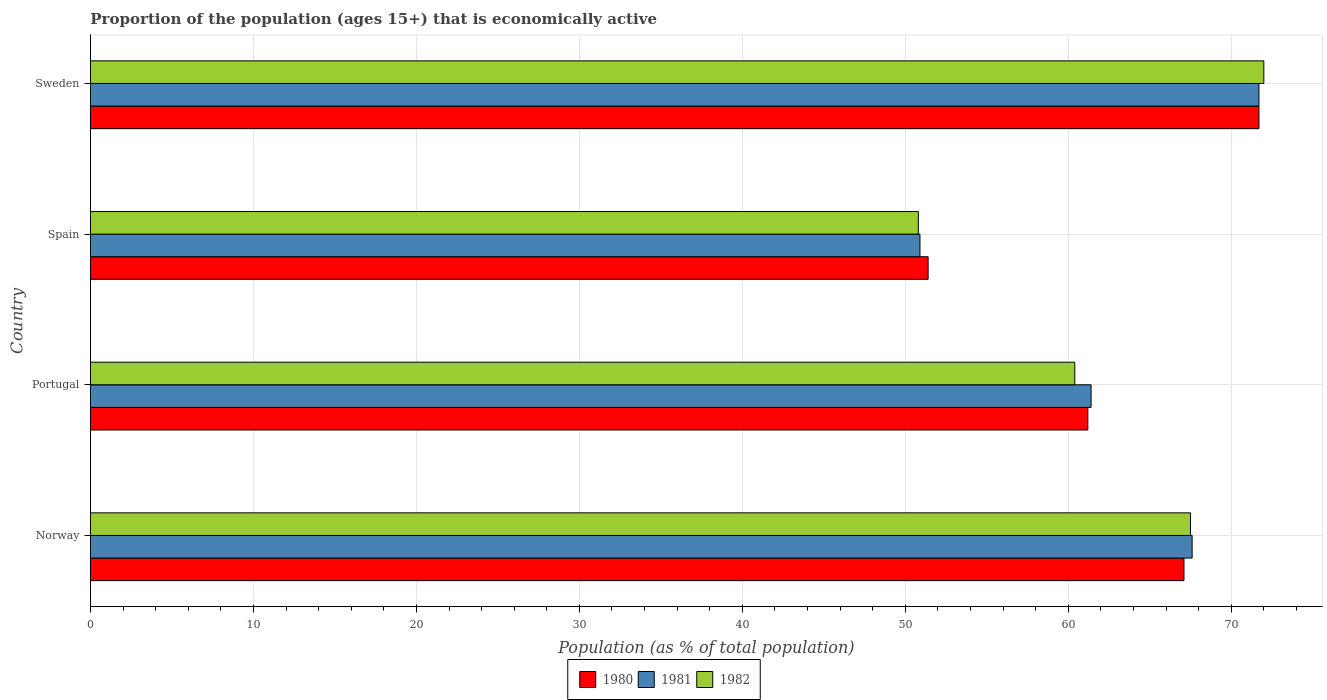How many groups of bars are there?
Keep it short and to the point. 4. Are the number of bars per tick equal to the number of legend labels?
Your response must be concise. Yes. Are the number of bars on each tick of the Y-axis equal?
Provide a short and direct response. Yes. How many bars are there on the 4th tick from the top?
Provide a succinct answer. 3. How many bars are there on the 1st tick from the bottom?
Your answer should be very brief. 3. What is the label of the 1st group of bars from the top?
Provide a succinct answer. Sweden. What is the proportion of the population that is economically active in 1981 in Portugal?
Provide a short and direct response. 61.4. Across all countries, what is the maximum proportion of the population that is economically active in 1980?
Give a very brief answer. 71.7. Across all countries, what is the minimum proportion of the population that is economically active in 1980?
Your response must be concise. 51.4. In which country was the proportion of the population that is economically active in 1980 minimum?
Make the answer very short. Spain. What is the total proportion of the population that is economically active in 1982 in the graph?
Keep it short and to the point. 250.7. What is the difference between the proportion of the population that is economically active in 1981 in Spain and the proportion of the population that is economically active in 1980 in Portugal?
Make the answer very short. -10.3. What is the average proportion of the population that is economically active in 1980 per country?
Give a very brief answer. 62.85. What is the difference between the proportion of the population that is economically active in 1981 and proportion of the population that is economically active in 1980 in Norway?
Your response must be concise. 0.5. In how many countries, is the proportion of the population that is economically active in 1982 greater than 28 %?
Offer a terse response. 4. What is the ratio of the proportion of the population that is economically active in 1980 in Portugal to that in Spain?
Keep it short and to the point. 1.19. Is the proportion of the population that is economically active in 1980 in Portugal less than that in Spain?
Ensure brevity in your answer.  No. Is the difference between the proportion of the population that is economically active in 1981 in Portugal and Sweden greater than the difference between the proportion of the population that is economically active in 1980 in Portugal and Sweden?
Offer a very short reply. Yes. What is the difference between the highest and the lowest proportion of the population that is economically active in 1981?
Provide a succinct answer. 20.8. What does the 3rd bar from the top in Portugal represents?
Your response must be concise. 1980. Is it the case that in every country, the sum of the proportion of the population that is economically active in 1981 and proportion of the population that is economically active in 1980 is greater than the proportion of the population that is economically active in 1982?
Offer a very short reply. Yes. How many bars are there?
Keep it short and to the point. 12. Are all the bars in the graph horizontal?
Make the answer very short. Yes. How many countries are there in the graph?
Your answer should be very brief. 4. What is the difference between two consecutive major ticks on the X-axis?
Your response must be concise. 10. Does the graph contain any zero values?
Provide a short and direct response. No. Where does the legend appear in the graph?
Provide a succinct answer. Bottom center. What is the title of the graph?
Provide a succinct answer. Proportion of the population (ages 15+) that is economically active. Does "2012" appear as one of the legend labels in the graph?
Your response must be concise. No. What is the label or title of the X-axis?
Offer a very short reply. Population (as % of total population). What is the Population (as % of total population) of 1980 in Norway?
Offer a terse response. 67.1. What is the Population (as % of total population) of 1981 in Norway?
Your answer should be very brief. 67.6. What is the Population (as % of total population) of 1982 in Norway?
Provide a short and direct response. 67.5. What is the Population (as % of total population) in 1980 in Portugal?
Offer a very short reply. 61.2. What is the Population (as % of total population) of 1981 in Portugal?
Offer a very short reply. 61.4. What is the Population (as % of total population) in 1982 in Portugal?
Offer a terse response. 60.4. What is the Population (as % of total population) in 1980 in Spain?
Provide a short and direct response. 51.4. What is the Population (as % of total population) in 1981 in Spain?
Provide a succinct answer. 50.9. What is the Population (as % of total population) of 1982 in Spain?
Your response must be concise. 50.8. What is the Population (as % of total population) in 1980 in Sweden?
Keep it short and to the point. 71.7. What is the Population (as % of total population) in 1981 in Sweden?
Give a very brief answer. 71.7. Across all countries, what is the maximum Population (as % of total population) in 1980?
Offer a very short reply. 71.7. Across all countries, what is the maximum Population (as % of total population) of 1981?
Provide a short and direct response. 71.7. Across all countries, what is the maximum Population (as % of total population) in 1982?
Offer a very short reply. 72. Across all countries, what is the minimum Population (as % of total population) of 1980?
Your answer should be very brief. 51.4. Across all countries, what is the minimum Population (as % of total population) in 1981?
Provide a short and direct response. 50.9. Across all countries, what is the minimum Population (as % of total population) in 1982?
Your answer should be very brief. 50.8. What is the total Population (as % of total population) in 1980 in the graph?
Offer a terse response. 251.4. What is the total Population (as % of total population) in 1981 in the graph?
Your answer should be compact. 251.6. What is the total Population (as % of total population) of 1982 in the graph?
Your answer should be very brief. 250.7. What is the difference between the Population (as % of total population) of 1981 in Norway and that in Portugal?
Provide a succinct answer. 6.2. What is the difference between the Population (as % of total population) of 1982 in Norway and that in Portugal?
Provide a short and direct response. 7.1. What is the difference between the Population (as % of total population) in 1981 in Norway and that in Spain?
Offer a terse response. 16.7. What is the difference between the Population (as % of total population) in 1981 in Norway and that in Sweden?
Provide a succinct answer. -4.1. What is the difference between the Population (as % of total population) in 1982 in Norway and that in Sweden?
Offer a terse response. -4.5. What is the difference between the Population (as % of total population) of 1982 in Portugal and that in Sweden?
Give a very brief answer. -11.6. What is the difference between the Population (as % of total population) in 1980 in Spain and that in Sweden?
Ensure brevity in your answer.  -20.3. What is the difference between the Population (as % of total population) in 1981 in Spain and that in Sweden?
Your answer should be compact. -20.8. What is the difference between the Population (as % of total population) of 1982 in Spain and that in Sweden?
Offer a terse response. -21.2. What is the difference between the Population (as % of total population) of 1981 in Norway and the Population (as % of total population) of 1982 in Portugal?
Your response must be concise. 7.2. What is the difference between the Population (as % of total population) of 1980 in Norway and the Population (as % of total population) of 1982 in Spain?
Your answer should be compact. 16.3. What is the difference between the Population (as % of total population) in 1980 in Norway and the Population (as % of total population) in 1981 in Sweden?
Offer a very short reply. -4.6. What is the difference between the Population (as % of total population) of 1980 in Norway and the Population (as % of total population) of 1982 in Sweden?
Your response must be concise. -4.9. What is the difference between the Population (as % of total population) in 1981 in Norway and the Population (as % of total population) in 1982 in Sweden?
Provide a short and direct response. -4.4. What is the difference between the Population (as % of total population) of 1980 in Portugal and the Population (as % of total population) of 1981 in Spain?
Offer a terse response. 10.3. What is the difference between the Population (as % of total population) of 1980 in Portugal and the Population (as % of total population) of 1982 in Spain?
Your answer should be compact. 10.4. What is the difference between the Population (as % of total population) in 1980 in Portugal and the Population (as % of total population) in 1982 in Sweden?
Make the answer very short. -10.8. What is the difference between the Population (as % of total population) of 1980 in Spain and the Population (as % of total population) of 1981 in Sweden?
Your response must be concise. -20.3. What is the difference between the Population (as % of total population) of 1980 in Spain and the Population (as % of total population) of 1982 in Sweden?
Your answer should be compact. -20.6. What is the difference between the Population (as % of total population) of 1981 in Spain and the Population (as % of total population) of 1982 in Sweden?
Provide a short and direct response. -21.1. What is the average Population (as % of total population) in 1980 per country?
Your answer should be compact. 62.85. What is the average Population (as % of total population) of 1981 per country?
Your response must be concise. 62.9. What is the average Population (as % of total population) of 1982 per country?
Your response must be concise. 62.67. What is the difference between the Population (as % of total population) in 1980 and Population (as % of total population) in 1982 in Portugal?
Your answer should be very brief. 0.8. What is the difference between the Population (as % of total population) in 1980 and Population (as % of total population) in 1982 in Sweden?
Make the answer very short. -0.3. What is the difference between the Population (as % of total population) in 1981 and Population (as % of total population) in 1982 in Sweden?
Provide a succinct answer. -0.3. What is the ratio of the Population (as % of total population) of 1980 in Norway to that in Portugal?
Provide a succinct answer. 1.1. What is the ratio of the Population (as % of total population) of 1981 in Norway to that in Portugal?
Make the answer very short. 1.1. What is the ratio of the Population (as % of total population) of 1982 in Norway to that in Portugal?
Offer a terse response. 1.12. What is the ratio of the Population (as % of total population) of 1980 in Norway to that in Spain?
Your answer should be very brief. 1.31. What is the ratio of the Population (as % of total population) of 1981 in Norway to that in Spain?
Your answer should be compact. 1.33. What is the ratio of the Population (as % of total population) in 1982 in Norway to that in Spain?
Your response must be concise. 1.33. What is the ratio of the Population (as % of total population) in 1980 in Norway to that in Sweden?
Offer a very short reply. 0.94. What is the ratio of the Population (as % of total population) in 1981 in Norway to that in Sweden?
Provide a succinct answer. 0.94. What is the ratio of the Population (as % of total population) in 1982 in Norway to that in Sweden?
Provide a succinct answer. 0.94. What is the ratio of the Population (as % of total population) of 1980 in Portugal to that in Spain?
Your response must be concise. 1.19. What is the ratio of the Population (as % of total population) of 1981 in Portugal to that in Spain?
Offer a terse response. 1.21. What is the ratio of the Population (as % of total population) of 1982 in Portugal to that in Spain?
Offer a terse response. 1.19. What is the ratio of the Population (as % of total population) of 1980 in Portugal to that in Sweden?
Provide a short and direct response. 0.85. What is the ratio of the Population (as % of total population) of 1981 in Portugal to that in Sweden?
Your response must be concise. 0.86. What is the ratio of the Population (as % of total population) of 1982 in Portugal to that in Sweden?
Offer a very short reply. 0.84. What is the ratio of the Population (as % of total population) of 1980 in Spain to that in Sweden?
Provide a short and direct response. 0.72. What is the ratio of the Population (as % of total population) in 1981 in Spain to that in Sweden?
Keep it short and to the point. 0.71. What is the ratio of the Population (as % of total population) in 1982 in Spain to that in Sweden?
Offer a terse response. 0.71. What is the difference between the highest and the second highest Population (as % of total population) in 1982?
Give a very brief answer. 4.5. What is the difference between the highest and the lowest Population (as % of total population) of 1980?
Your answer should be very brief. 20.3. What is the difference between the highest and the lowest Population (as % of total population) in 1981?
Your response must be concise. 20.8. What is the difference between the highest and the lowest Population (as % of total population) in 1982?
Offer a very short reply. 21.2. 